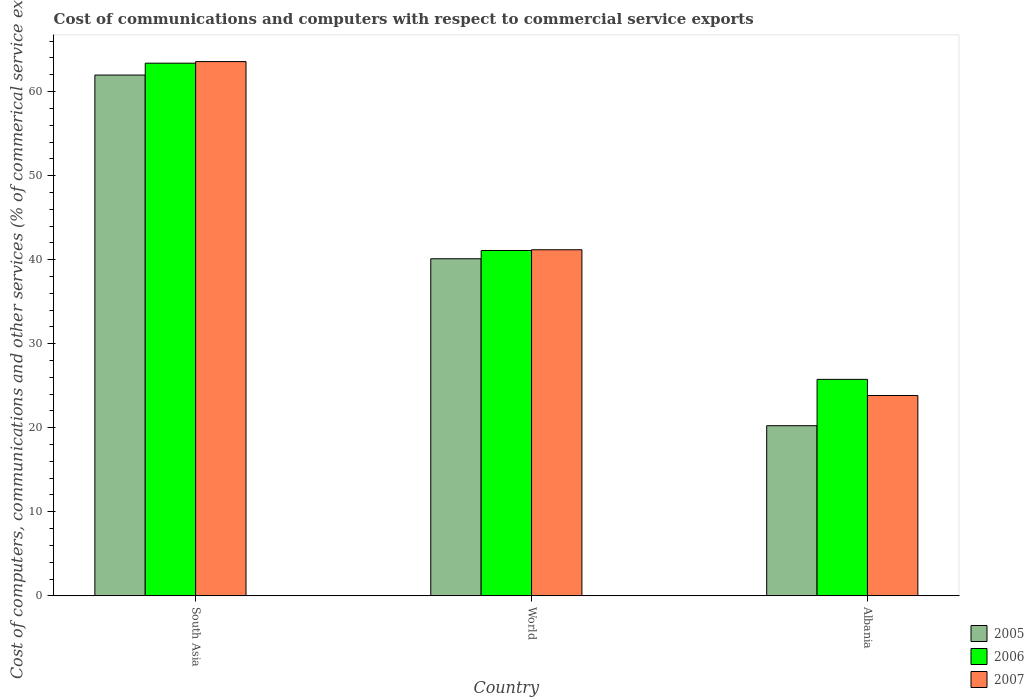How many groups of bars are there?
Offer a very short reply. 3. Are the number of bars on each tick of the X-axis equal?
Your answer should be very brief. Yes. How many bars are there on the 2nd tick from the right?
Keep it short and to the point. 3. What is the label of the 3rd group of bars from the left?
Your answer should be very brief. Albania. In how many cases, is the number of bars for a given country not equal to the number of legend labels?
Offer a very short reply. 0. What is the cost of communications and computers in 2005 in South Asia?
Offer a terse response. 61.97. Across all countries, what is the maximum cost of communications and computers in 2006?
Provide a succinct answer. 63.38. Across all countries, what is the minimum cost of communications and computers in 2005?
Offer a terse response. 20.24. In which country was the cost of communications and computers in 2005 maximum?
Ensure brevity in your answer.  South Asia. In which country was the cost of communications and computers in 2005 minimum?
Offer a terse response. Albania. What is the total cost of communications and computers in 2007 in the graph?
Your answer should be very brief. 128.58. What is the difference between the cost of communications and computers in 2006 in Albania and that in World?
Offer a terse response. -15.33. What is the difference between the cost of communications and computers in 2007 in South Asia and the cost of communications and computers in 2005 in World?
Provide a succinct answer. 23.46. What is the average cost of communications and computers in 2006 per country?
Ensure brevity in your answer.  43.41. What is the difference between the cost of communications and computers of/in 2005 and cost of communications and computers of/in 2007 in World?
Make the answer very short. -1.07. What is the ratio of the cost of communications and computers in 2007 in Albania to that in World?
Your answer should be compact. 0.58. Is the cost of communications and computers in 2006 in Albania less than that in South Asia?
Your response must be concise. Yes. Is the difference between the cost of communications and computers in 2005 in South Asia and World greater than the difference between the cost of communications and computers in 2007 in South Asia and World?
Keep it short and to the point. No. What is the difference between the highest and the second highest cost of communications and computers in 2006?
Your answer should be very brief. 15.33. What is the difference between the highest and the lowest cost of communications and computers in 2006?
Offer a terse response. 37.62. In how many countries, is the cost of communications and computers in 2007 greater than the average cost of communications and computers in 2007 taken over all countries?
Give a very brief answer. 1. Is the sum of the cost of communications and computers in 2005 in South Asia and World greater than the maximum cost of communications and computers in 2007 across all countries?
Your response must be concise. Yes. What does the 3rd bar from the left in South Asia represents?
Your answer should be very brief. 2007. Are all the bars in the graph horizontal?
Make the answer very short. No. How many countries are there in the graph?
Offer a terse response. 3. What is the difference between two consecutive major ticks on the Y-axis?
Give a very brief answer. 10. What is the title of the graph?
Provide a succinct answer. Cost of communications and computers with respect to commercial service exports. What is the label or title of the Y-axis?
Offer a terse response. Cost of computers, communications and other services (% of commerical service exports). What is the Cost of computers, communications and other services (% of commerical service exports) in 2005 in South Asia?
Keep it short and to the point. 61.97. What is the Cost of computers, communications and other services (% of commerical service exports) of 2006 in South Asia?
Make the answer very short. 63.38. What is the Cost of computers, communications and other services (% of commerical service exports) in 2007 in South Asia?
Offer a very short reply. 63.57. What is the Cost of computers, communications and other services (% of commerical service exports) of 2005 in World?
Ensure brevity in your answer.  40.11. What is the Cost of computers, communications and other services (% of commerical service exports) of 2006 in World?
Keep it short and to the point. 41.09. What is the Cost of computers, communications and other services (% of commerical service exports) of 2007 in World?
Ensure brevity in your answer.  41.18. What is the Cost of computers, communications and other services (% of commerical service exports) in 2005 in Albania?
Provide a succinct answer. 20.24. What is the Cost of computers, communications and other services (% of commerical service exports) in 2006 in Albania?
Provide a short and direct response. 25.76. What is the Cost of computers, communications and other services (% of commerical service exports) of 2007 in Albania?
Your answer should be very brief. 23.83. Across all countries, what is the maximum Cost of computers, communications and other services (% of commerical service exports) of 2005?
Offer a terse response. 61.97. Across all countries, what is the maximum Cost of computers, communications and other services (% of commerical service exports) of 2006?
Your answer should be very brief. 63.38. Across all countries, what is the maximum Cost of computers, communications and other services (% of commerical service exports) of 2007?
Offer a terse response. 63.57. Across all countries, what is the minimum Cost of computers, communications and other services (% of commerical service exports) in 2005?
Offer a terse response. 20.24. Across all countries, what is the minimum Cost of computers, communications and other services (% of commerical service exports) of 2006?
Ensure brevity in your answer.  25.76. Across all countries, what is the minimum Cost of computers, communications and other services (% of commerical service exports) of 2007?
Your response must be concise. 23.83. What is the total Cost of computers, communications and other services (% of commerical service exports) of 2005 in the graph?
Your answer should be compact. 122.32. What is the total Cost of computers, communications and other services (% of commerical service exports) of 2006 in the graph?
Provide a short and direct response. 130.23. What is the total Cost of computers, communications and other services (% of commerical service exports) in 2007 in the graph?
Offer a very short reply. 128.58. What is the difference between the Cost of computers, communications and other services (% of commerical service exports) in 2005 in South Asia and that in World?
Provide a short and direct response. 21.86. What is the difference between the Cost of computers, communications and other services (% of commerical service exports) of 2006 in South Asia and that in World?
Your answer should be compact. 22.29. What is the difference between the Cost of computers, communications and other services (% of commerical service exports) in 2007 in South Asia and that in World?
Your answer should be very brief. 22.39. What is the difference between the Cost of computers, communications and other services (% of commerical service exports) of 2005 in South Asia and that in Albania?
Offer a terse response. 41.72. What is the difference between the Cost of computers, communications and other services (% of commerical service exports) in 2006 in South Asia and that in Albania?
Give a very brief answer. 37.62. What is the difference between the Cost of computers, communications and other services (% of commerical service exports) of 2007 in South Asia and that in Albania?
Provide a succinct answer. 39.74. What is the difference between the Cost of computers, communications and other services (% of commerical service exports) of 2005 in World and that in Albania?
Your answer should be compact. 19.86. What is the difference between the Cost of computers, communications and other services (% of commerical service exports) of 2006 in World and that in Albania?
Your answer should be compact. 15.33. What is the difference between the Cost of computers, communications and other services (% of commerical service exports) of 2007 in World and that in Albania?
Offer a terse response. 17.34. What is the difference between the Cost of computers, communications and other services (% of commerical service exports) of 2005 in South Asia and the Cost of computers, communications and other services (% of commerical service exports) of 2006 in World?
Make the answer very short. 20.88. What is the difference between the Cost of computers, communications and other services (% of commerical service exports) of 2005 in South Asia and the Cost of computers, communications and other services (% of commerical service exports) of 2007 in World?
Ensure brevity in your answer.  20.79. What is the difference between the Cost of computers, communications and other services (% of commerical service exports) of 2006 in South Asia and the Cost of computers, communications and other services (% of commerical service exports) of 2007 in World?
Provide a succinct answer. 22.2. What is the difference between the Cost of computers, communications and other services (% of commerical service exports) in 2005 in South Asia and the Cost of computers, communications and other services (% of commerical service exports) in 2006 in Albania?
Your response must be concise. 36.21. What is the difference between the Cost of computers, communications and other services (% of commerical service exports) of 2005 in South Asia and the Cost of computers, communications and other services (% of commerical service exports) of 2007 in Albania?
Offer a very short reply. 38.13. What is the difference between the Cost of computers, communications and other services (% of commerical service exports) of 2006 in South Asia and the Cost of computers, communications and other services (% of commerical service exports) of 2007 in Albania?
Your answer should be very brief. 39.55. What is the difference between the Cost of computers, communications and other services (% of commerical service exports) in 2005 in World and the Cost of computers, communications and other services (% of commerical service exports) in 2006 in Albania?
Your answer should be compact. 14.35. What is the difference between the Cost of computers, communications and other services (% of commerical service exports) in 2005 in World and the Cost of computers, communications and other services (% of commerical service exports) in 2007 in Albania?
Offer a very short reply. 16.27. What is the difference between the Cost of computers, communications and other services (% of commerical service exports) in 2006 in World and the Cost of computers, communications and other services (% of commerical service exports) in 2007 in Albania?
Keep it short and to the point. 17.26. What is the average Cost of computers, communications and other services (% of commerical service exports) of 2005 per country?
Offer a terse response. 40.77. What is the average Cost of computers, communications and other services (% of commerical service exports) of 2006 per country?
Provide a short and direct response. 43.41. What is the average Cost of computers, communications and other services (% of commerical service exports) of 2007 per country?
Your response must be concise. 42.86. What is the difference between the Cost of computers, communications and other services (% of commerical service exports) in 2005 and Cost of computers, communications and other services (% of commerical service exports) in 2006 in South Asia?
Make the answer very short. -1.41. What is the difference between the Cost of computers, communications and other services (% of commerical service exports) of 2005 and Cost of computers, communications and other services (% of commerical service exports) of 2007 in South Asia?
Your answer should be very brief. -1.6. What is the difference between the Cost of computers, communications and other services (% of commerical service exports) in 2006 and Cost of computers, communications and other services (% of commerical service exports) in 2007 in South Asia?
Provide a succinct answer. -0.19. What is the difference between the Cost of computers, communications and other services (% of commerical service exports) of 2005 and Cost of computers, communications and other services (% of commerical service exports) of 2006 in World?
Ensure brevity in your answer.  -0.98. What is the difference between the Cost of computers, communications and other services (% of commerical service exports) of 2005 and Cost of computers, communications and other services (% of commerical service exports) of 2007 in World?
Provide a short and direct response. -1.07. What is the difference between the Cost of computers, communications and other services (% of commerical service exports) in 2006 and Cost of computers, communications and other services (% of commerical service exports) in 2007 in World?
Ensure brevity in your answer.  -0.09. What is the difference between the Cost of computers, communications and other services (% of commerical service exports) of 2005 and Cost of computers, communications and other services (% of commerical service exports) of 2006 in Albania?
Provide a succinct answer. -5.51. What is the difference between the Cost of computers, communications and other services (% of commerical service exports) of 2005 and Cost of computers, communications and other services (% of commerical service exports) of 2007 in Albania?
Your response must be concise. -3.59. What is the difference between the Cost of computers, communications and other services (% of commerical service exports) of 2006 and Cost of computers, communications and other services (% of commerical service exports) of 2007 in Albania?
Your answer should be compact. 1.92. What is the ratio of the Cost of computers, communications and other services (% of commerical service exports) in 2005 in South Asia to that in World?
Offer a terse response. 1.54. What is the ratio of the Cost of computers, communications and other services (% of commerical service exports) of 2006 in South Asia to that in World?
Give a very brief answer. 1.54. What is the ratio of the Cost of computers, communications and other services (% of commerical service exports) in 2007 in South Asia to that in World?
Your response must be concise. 1.54. What is the ratio of the Cost of computers, communications and other services (% of commerical service exports) in 2005 in South Asia to that in Albania?
Your answer should be very brief. 3.06. What is the ratio of the Cost of computers, communications and other services (% of commerical service exports) of 2006 in South Asia to that in Albania?
Your answer should be very brief. 2.46. What is the ratio of the Cost of computers, communications and other services (% of commerical service exports) in 2007 in South Asia to that in Albania?
Keep it short and to the point. 2.67. What is the ratio of the Cost of computers, communications and other services (% of commerical service exports) in 2005 in World to that in Albania?
Your answer should be compact. 1.98. What is the ratio of the Cost of computers, communications and other services (% of commerical service exports) in 2006 in World to that in Albania?
Offer a very short reply. 1.6. What is the ratio of the Cost of computers, communications and other services (% of commerical service exports) in 2007 in World to that in Albania?
Your response must be concise. 1.73. What is the difference between the highest and the second highest Cost of computers, communications and other services (% of commerical service exports) of 2005?
Keep it short and to the point. 21.86. What is the difference between the highest and the second highest Cost of computers, communications and other services (% of commerical service exports) in 2006?
Your answer should be compact. 22.29. What is the difference between the highest and the second highest Cost of computers, communications and other services (% of commerical service exports) of 2007?
Provide a succinct answer. 22.39. What is the difference between the highest and the lowest Cost of computers, communications and other services (% of commerical service exports) in 2005?
Give a very brief answer. 41.72. What is the difference between the highest and the lowest Cost of computers, communications and other services (% of commerical service exports) of 2006?
Your response must be concise. 37.62. What is the difference between the highest and the lowest Cost of computers, communications and other services (% of commerical service exports) of 2007?
Provide a short and direct response. 39.74. 